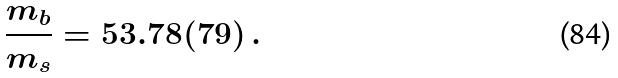<formula> <loc_0><loc_0><loc_500><loc_500>\frac { m _ { b } } { m _ { s } } = 5 3 . 7 8 ( 7 9 ) \, .</formula> 